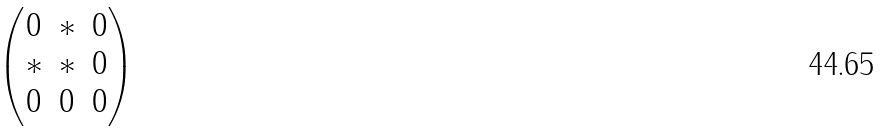<formula> <loc_0><loc_0><loc_500><loc_500>\begin{pmatrix} 0 & * & 0 \\ * & * & 0 \\ 0 & 0 & 0 \end{pmatrix}</formula> 